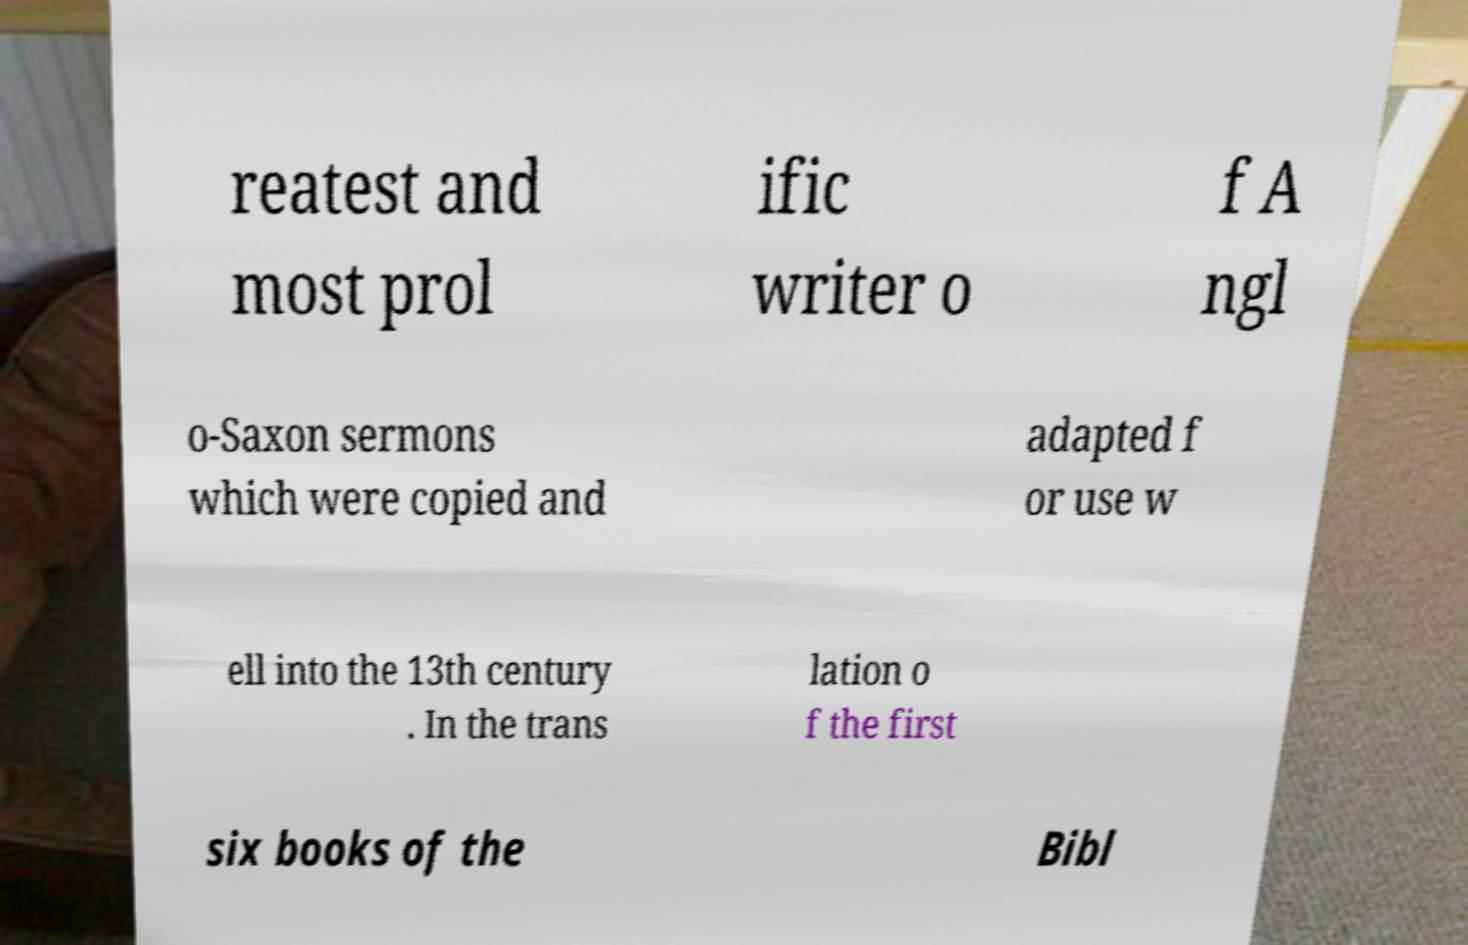Please identify and transcribe the text found in this image. reatest and most prol ific writer o f A ngl o-Saxon sermons which were copied and adapted f or use w ell into the 13th century . In the trans lation o f the first six books of the Bibl 